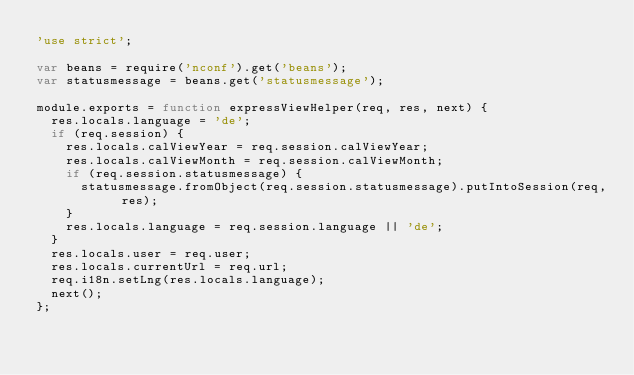Convert code to text. <code><loc_0><loc_0><loc_500><loc_500><_JavaScript_>'use strict';

var beans = require('nconf').get('beans');
var statusmessage = beans.get('statusmessage');

module.exports = function expressViewHelper(req, res, next) {
  res.locals.language = 'de';
  if (req.session) {
    res.locals.calViewYear = req.session.calViewYear;
    res.locals.calViewMonth = req.session.calViewMonth;
    if (req.session.statusmessage) {
      statusmessage.fromObject(req.session.statusmessage).putIntoSession(req, res);
    }
    res.locals.language = req.session.language || 'de';
  }
  res.locals.user = req.user;
  res.locals.currentUrl = req.url;
  req.i18n.setLng(res.locals.language);
  next();
};
</code> 